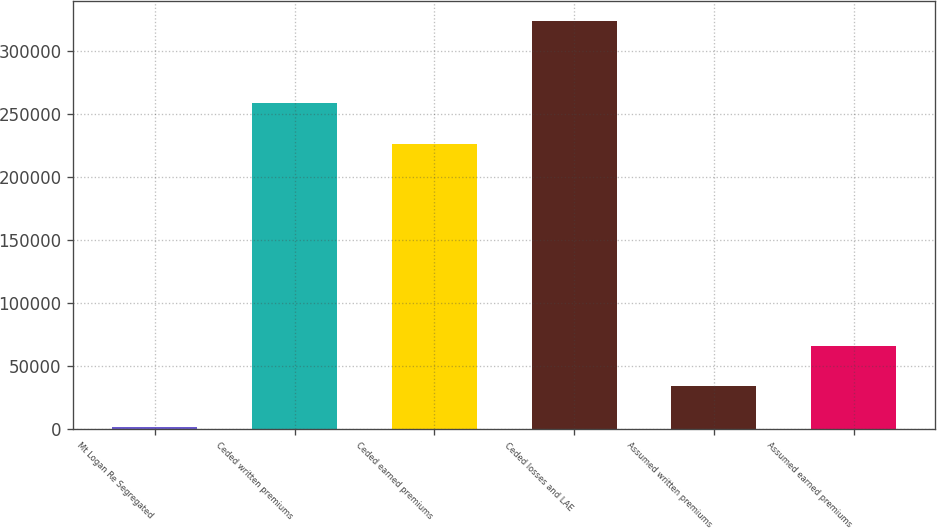<chart> <loc_0><loc_0><loc_500><loc_500><bar_chart><fcel>Mt Logan Re Segregated<fcel>Ceded written premiums<fcel>Ceded earned premiums<fcel>Ceded losses and LAE<fcel>Assumed written premiums<fcel>Assumed earned premiums<nl><fcel>2017<fcel>258670<fcel>226505<fcel>323664<fcel>34181.7<fcel>66346.4<nl></chart> 